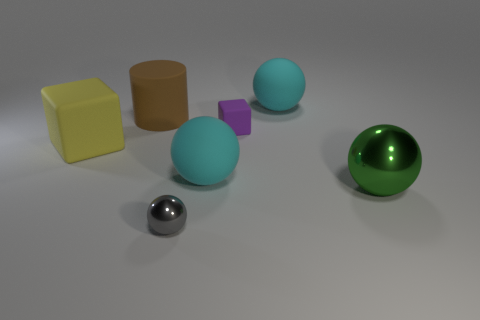There is a cyan sphere that is in front of the big yellow object; what is its material?
Your response must be concise. Rubber. Are the small thing to the left of the tiny matte thing and the yellow thing made of the same material?
Provide a succinct answer. No. Are there any big purple matte balls?
Provide a short and direct response. No. The small object that is made of the same material as the large brown cylinder is what color?
Your answer should be very brief. Purple. What is the color of the metallic sphere that is on the left side of the rubber block that is behind the rubber block on the left side of the tiny purple rubber block?
Your response must be concise. Gray. There is a purple thing; does it have the same size as the sphere behind the tiny purple matte cube?
Give a very brief answer. No. How many objects are blocks that are on the right side of the small sphere or yellow matte cubes left of the green thing?
Give a very brief answer. 2. There is a object that is the same size as the gray ball; what shape is it?
Provide a short and direct response. Cube. There is a shiny object that is right of the shiny object left of the big cyan thing in front of the large yellow rubber object; what is its shape?
Your response must be concise. Sphere. Are there an equal number of big yellow things that are on the left side of the large yellow matte thing and rubber objects?
Provide a short and direct response. No. 